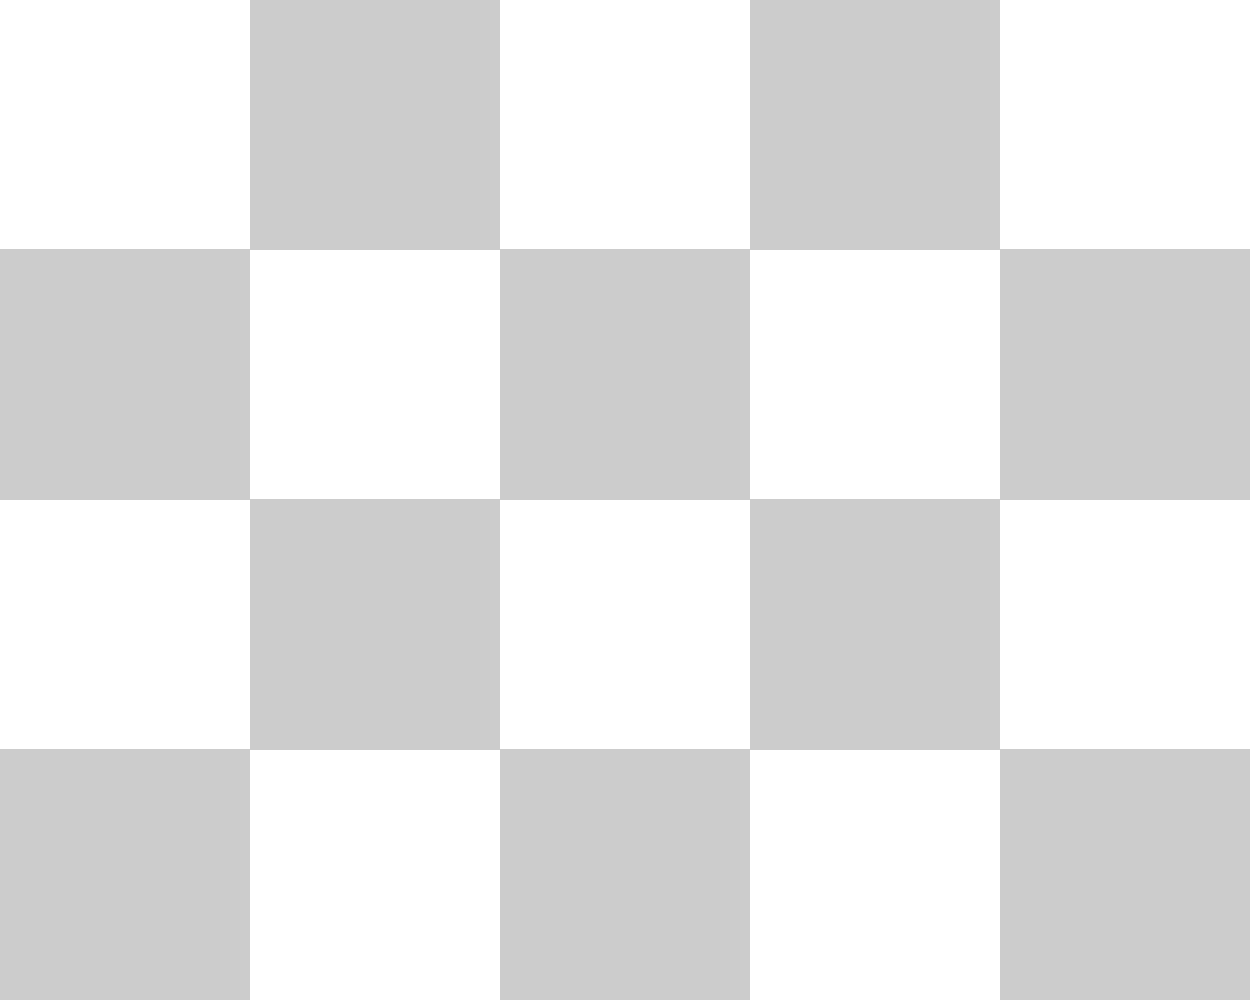Based on the phonetic inventory represented in the chart, which Indian language has the most diverse set of consonantal features among those listed? To determine which language has the most diverse set of consonantal features, we need to count the number of features (represented by checkmarks) for each language:

1. Hindi:
   - Retroflex: ✓
   - Aspirated: ✓
   - Breathy: ✓
   - Dental: ✓
   Total: 4 features

2. Bengali:
   - Retroflex: ✓
   - Aspirated: ✓
   - Breathy: ✗
   - Dental: ✗
   Total: 2 features

3. Tamil:
   - Retroflex: ✓
   - Aspirated: ✗
   - Breathy: ✗
   - Dental: ✓
   Total: 2 features

4. Telugu:
   - Retroflex: ✓
   - Aspirated: ✗
   - Breathy: ✗
   - Dental: ✓
   Total: 2 features

5. Marathi:
   - Retroflex: ✓
   - Aspirated: ✓
   - Breathy: ✗
   - Dental: ✓
   Total: 3 features

Comparing the totals, we can see that Hindi has the highest number of features (4) among the listed languages, making it the most diverse in terms of consonantal features.
Answer: Hindi 